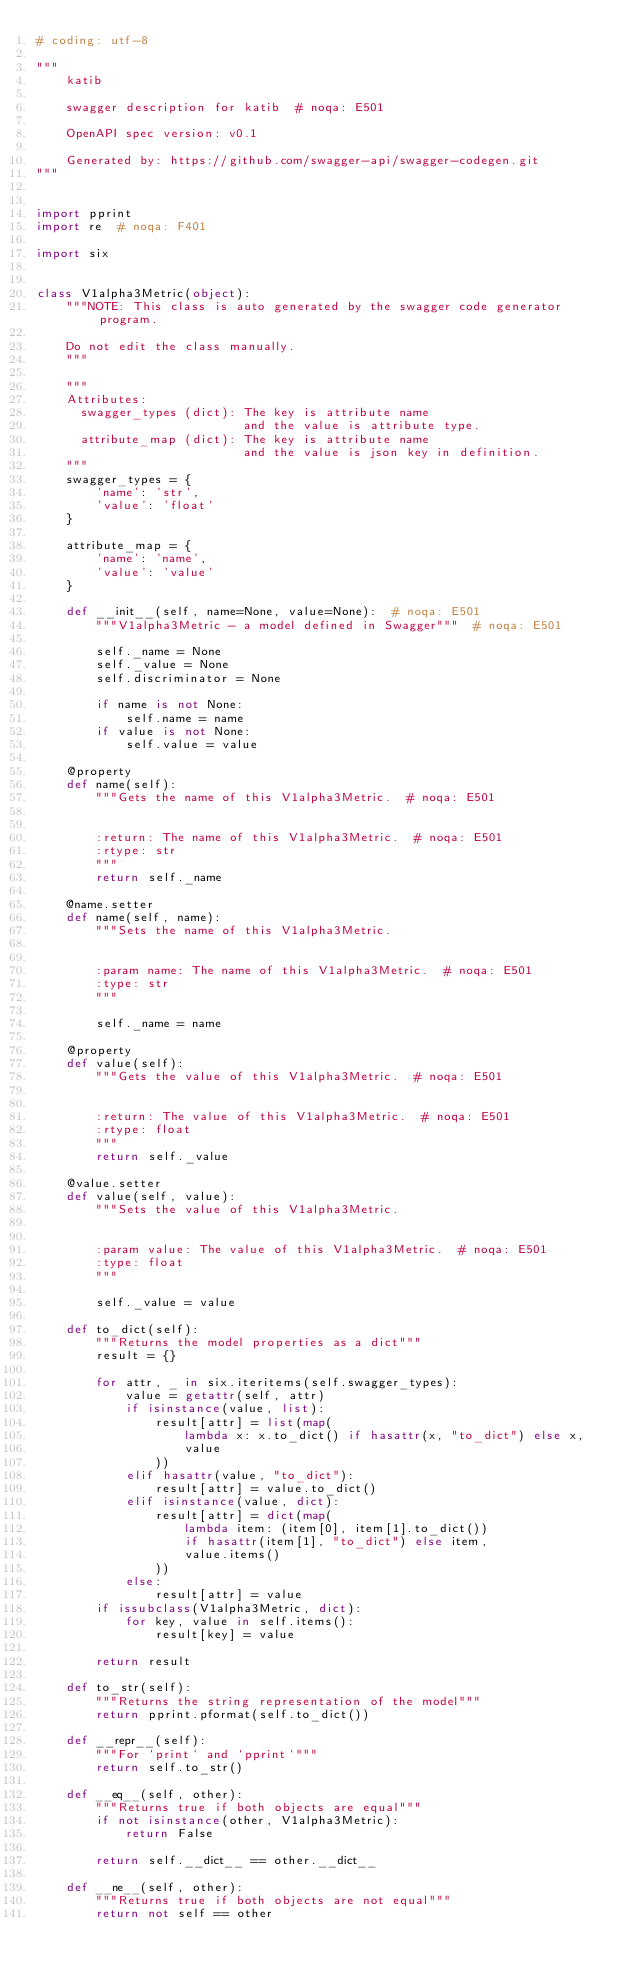<code> <loc_0><loc_0><loc_500><loc_500><_Python_># coding: utf-8

"""
    katib

    swagger description for katib  # noqa: E501

    OpenAPI spec version: v0.1
    
    Generated by: https://github.com/swagger-api/swagger-codegen.git
"""


import pprint
import re  # noqa: F401

import six


class V1alpha3Metric(object):
    """NOTE: This class is auto generated by the swagger code generator program.

    Do not edit the class manually.
    """

    """
    Attributes:
      swagger_types (dict): The key is attribute name
                            and the value is attribute type.
      attribute_map (dict): The key is attribute name
                            and the value is json key in definition.
    """
    swagger_types = {
        'name': 'str',
        'value': 'float'
    }

    attribute_map = {
        'name': 'name',
        'value': 'value'
    }

    def __init__(self, name=None, value=None):  # noqa: E501
        """V1alpha3Metric - a model defined in Swagger"""  # noqa: E501

        self._name = None
        self._value = None
        self.discriminator = None

        if name is not None:
            self.name = name
        if value is not None:
            self.value = value

    @property
    def name(self):
        """Gets the name of this V1alpha3Metric.  # noqa: E501


        :return: The name of this V1alpha3Metric.  # noqa: E501
        :rtype: str
        """
        return self._name

    @name.setter
    def name(self, name):
        """Sets the name of this V1alpha3Metric.


        :param name: The name of this V1alpha3Metric.  # noqa: E501
        :type: str
        """

        self._name = name

    @property
    def value(self):
        """Gets the value of this V1alpha3Metric.  # noqa: E501


        :return: The value of this V1alpha3Metric.  # noqa: E501
        :rtype: float
        """
        return self._value

    @value.setter
    def value(self, value):
        """Sets the value of this V1alpha3Metric.


        :param value: The value of this V1alpha3Metric.  # noqa: E501
        :type: float
        """

        self._value = value

    def to_dict(self):
        """Returns the model properties as a dict"""
        result = {}

        for attr, _ in six.iteritems(self.swagger_types):
            value = getattr(self, attr)
            if isinstance(value, list):
                result[attr] = list(map(
                    lambda x: x.to_dict() if hasattr(x, "to_dict") else x,
                    value
                ))
            elif hasattr(value, "to_dict"):
                result[attr] = value.to_dict()
            elif isinstance(value, dict):
                result[attr] = dict(map(
                    lambda item: (item[0], item[1].to_dict())
                    if hasattr(item[1], "to_dict") else item,
                    value.items()
                ))
            else:
                result[attr] = value
        if issubclass(V1alpha3Metric, dict):
            for key, value in self.items():
                result[key] = value

        return result

    def to_str(self):
        """Returns the string representation of the model"""
        return pprint.pformat(self.to_dict())

    def __repr__(self):
        """For `print` and `pprint`"""
        return self.to_str()

    def __eq__(self, other):
        """Returns true if both objects are equal"""
        if not isinstance(other, V1alpha3Metric):
            return False

        return self.__dict__ == other.__dict__

    def __ne__(self, other):
        """Returns true if both objects are not equal"""
        return not self == other
</code> 